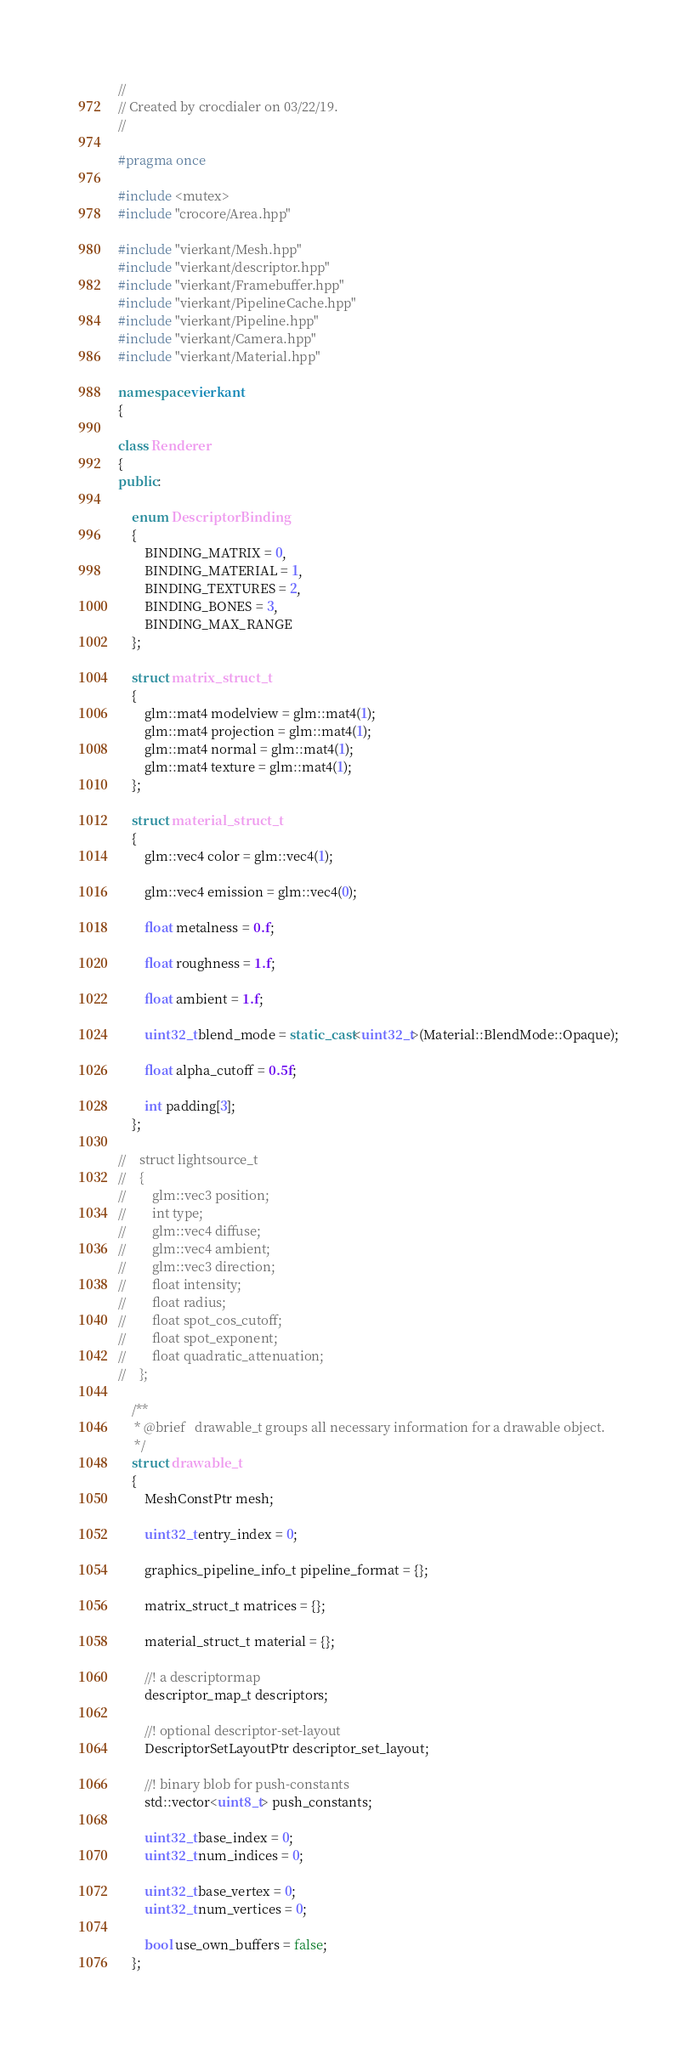<code> <loc_0><loc_0><loc_500><loc_500><_C++_>//
// Created by crocdialer on 03/22/19.
//

#pragma once

#include <mutex>
#include "crocore/Area.hpp"

#include "vierkant/Mesh.hpp"
#include "vierkant/descriptor.hpp"
#include "vierkant/Framebuffer.hpp"
#include "vierkant/PipelineCache.hpp"
#include "vierkant/Pipeline.hpp"
#include "vierkant/Camera.hpp"
#include "vierkant/Material.hpp"

namespace vierkant
{

class Renderer
{
public:

    enum DescriptorBinding
    {
        BINDING_MATRIX = 0,
        BINDING_MATERIAL = 1,
        BINDING_TEXTURES = 2,
        BINDING_BONES = 3,
        BINDING_MAX_RANGE
    };

    struct matrix_struct_t
    {
        glm::mat4 modelview = glm::mat4(1);
        glm::mat4 projection = glm::mat4(1);
        glm::mat4 normal = glm::mat4(1);
        glm::mat4 texture = glm::mat4(1);
    };

    struct material_struct_t
    {
        glm::vec4 color = glm::vec4(1);

        glm::vec4 emission = glm::vec4(0);

        float metalness = 0.f;

        float roughness = 1.f;

        float ambient = 1.f;

        uint32_t blend_mode = static_cast<uint32_t>(Material::BlendMode::Opaque);

        float alpha_cutoff = 0.5f;

        int padding[3];
    };

//    struct lightsource_t
//    {
//        glm::vec3 position;
//        int type;
//        glm::vec4 diffuse;
//        glm::vec4 ambient;
//        glm::vec3 direction;
//        float intensity;
//        float radius;
//        float spot_cos_cutoff;
//        float spot_exponent;
//        float quadratic_attenuation;
//    };

    /**
     * @brief   drawable_t groups all necessary information for a drawable object.
     */
    struct drawable_t
    {
        MeshConstPtr mesh;

        uint32_t entry_index = 0;

        graphics_pipeline_info_t pipeline_format = {};

        matrix_struct_t matrices = {};

        material_struct_t material = {};

        //! a descriptormap
        descriptor_map_t descriptors;

        //! optional descriptor-set-layout
        DescriptorSetLayoutPtr descriptor_set_layout;

        //! binary blob for push-constants
        std::vector<uint8_t> push_constants;

        uint32_t base_index = 0;
        uint32_t num_indices = 0;

        uint32_t base_vertex = 0;
        uint32_t num_vertices = 0;

        bool use_own_buffers = false;
    };
</code> 